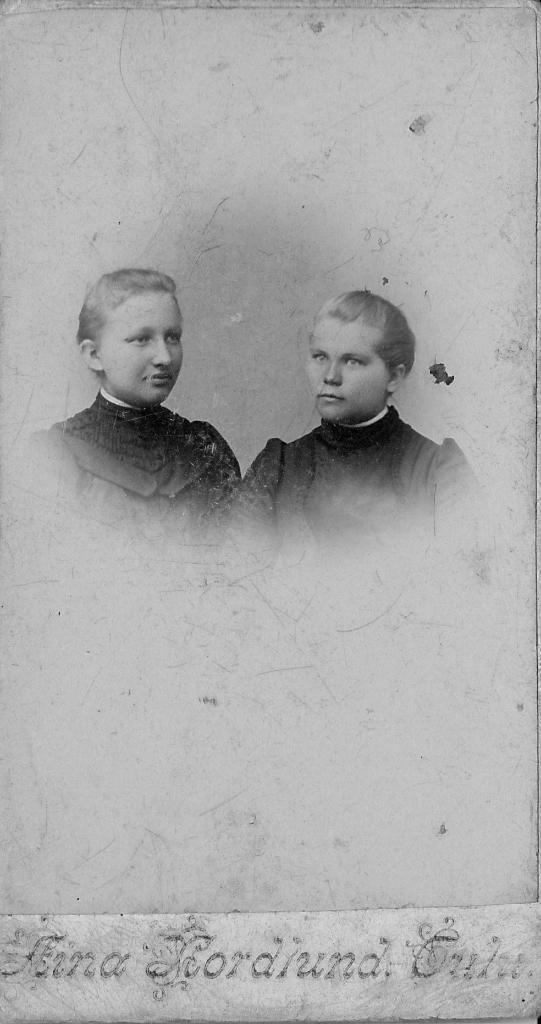What type of image is present in the picture? The image contains an old photograph. How many people are in the old photograph? There are two persons in the old photograph. What can be observed about the clothing of the persons in the photograph? The persons are wearing black and white colored dresses. Is there any text present in the image? Yes, there is text written at the bottom of the image. What type of cabbage is growing in the square shown in the image? There is no square or cabbage present in the image; it contains an old photograph with two persons wearing black and white colored dresses and text at the bottom. 